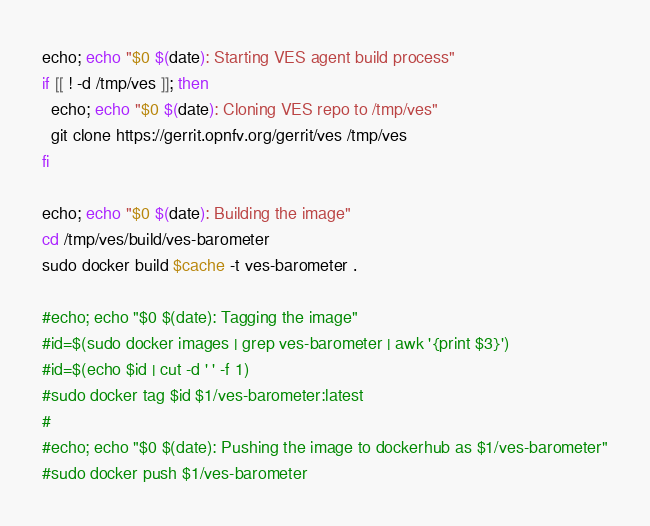Convert code to text. <code><loc_0><loc_0><loc_500><loc_500><_Bash_>
echo; echo "$0 $(date): Starting VES agent build process"
if [[ ! -d /tmp/ves ]]; then
  echo; echo "$0 $(date): Cloning VES repo to /tmp/ves"
  git clone https://gerrit.opnfv.org/gerrit/ves /tmp/ves
fi

echo; echo "$0 $(date): Building the image"
cd /tmp/ves/build/ves-barometer
sudo docker build $cache -t ves-barometer .

#echo; echo "$0 $(date): Tagging the image"
#id=$(sudo docker images | grep ves-barometer | awk '{print $3}')
#id=$(echo $id | cut -d ' ' -f 1)
#sudo docker tag $id $1/ves-barometer:latest
#
#echo; echo "$0 $(date): Pushing the image to dockerhub as $1/ves-barometer"
#sudo docker push $1/ves-barometer
</code> 